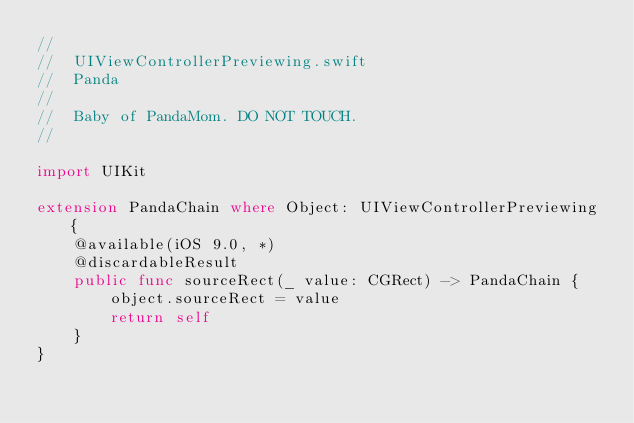Convert code to text. <code><loc_0><loc_0><loc_500><loc_500><_Swift_>//
//  UIViewControllerPreviewing.swift
//  Panda
//
//  Baby of PandaMom. DO NOT TOUCH.
//

import UIKit

extension PandaChain where Object: UIViewControllerPreviewing {
    @available(iOS 9.0, *)
    @discardableResult
    public func sourceRect(_ value: CGRect) -> PandaChain {
        object.sourceRect = value
        return self
    }
}
</code> 